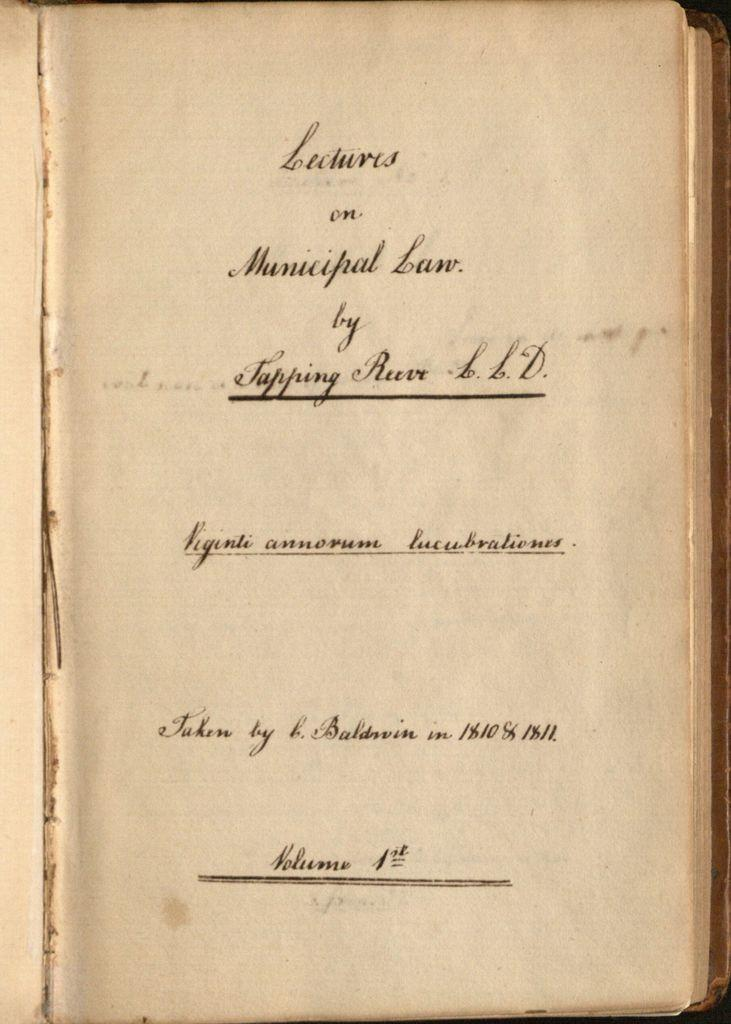<image>
Offer a succinct explanation of the picture presented. An old book is open to show the title Lectures on Municipal Law. 